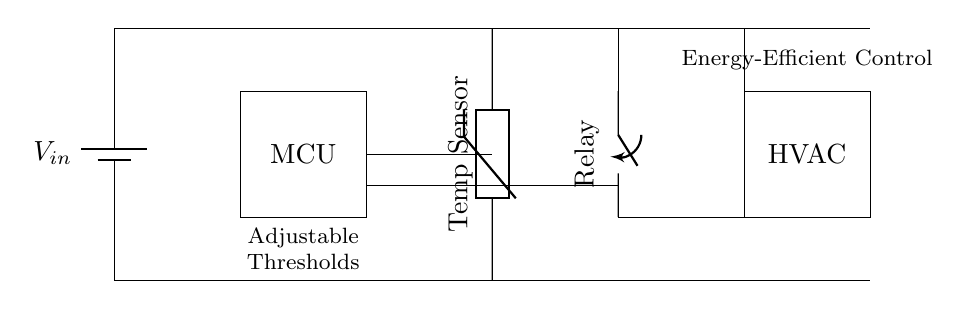What type of sensor is used in this circuit? The circuit includes a thermistor, which is a type of temperature sensor that changes resistance with temperature variations.
Answer: Thermistor What is the function of the microcontroller in this circuit? The microcontroller (MCU) is responsible for processing the input from the temperature sensor and controlling the relay to manage the HVAC system based on the temperature readings.
Answer: Processing How many major components are present in the circuit diagram? The components include a battery, microcontroller, temperature sensor, relay, and HVAC system, totaling five major components in the circuit.
Answer: Five What does the relay control in this circuit? The relay controls the operation of the HVAC system, acting as a switch that turns it on or off based on the signals from the microcontroller.
Answer: HVAC system What does "Adjustable Thresholds" refer to in the circuit? "Adjustable Thresholds" indicates that the temperature settings can be customized, allowing users to set specific temperature levels at which the HVAC system will activate or deactivate.
Answer: Customizable settings How does the temperature sensor communicate with the microcontroller? The temperature sensor provides analog or digital signals to the microcontroller, which interprets these signals to determine the current temperature and takes actions based on pre-set thresholds.
Answer: Signal transmission What is the primary purpose of this circuit? The primary purpose is to create an energy-efficient control system for heating and cooling in a household using a smart thermostat that responds to temperature changes.
Answer: Energy-efficient control 